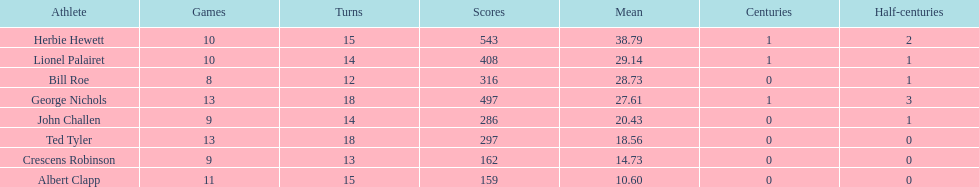Name a player that play in no more than 13 innings. Bill Roe. 